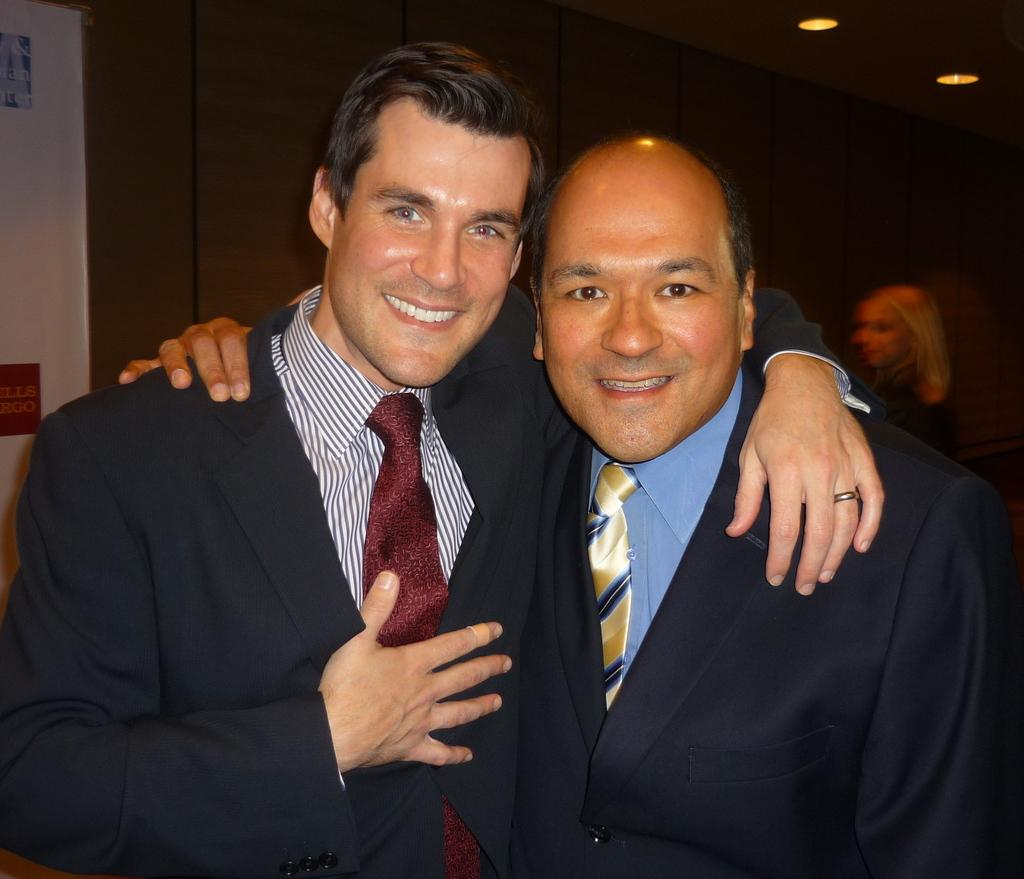How many people are present in the image? There are two people in the image. What is the facial expression of the people in the image? Both people are smiling. What can be seen in the background of the image? There are ceiling lights, a person, a wall, and boards on the wall in the background. What type of patch is being used to wash the boards on the wall in the image? There is no patch or washing activity present in the image; the boards on the wall are simply visible in the background. 